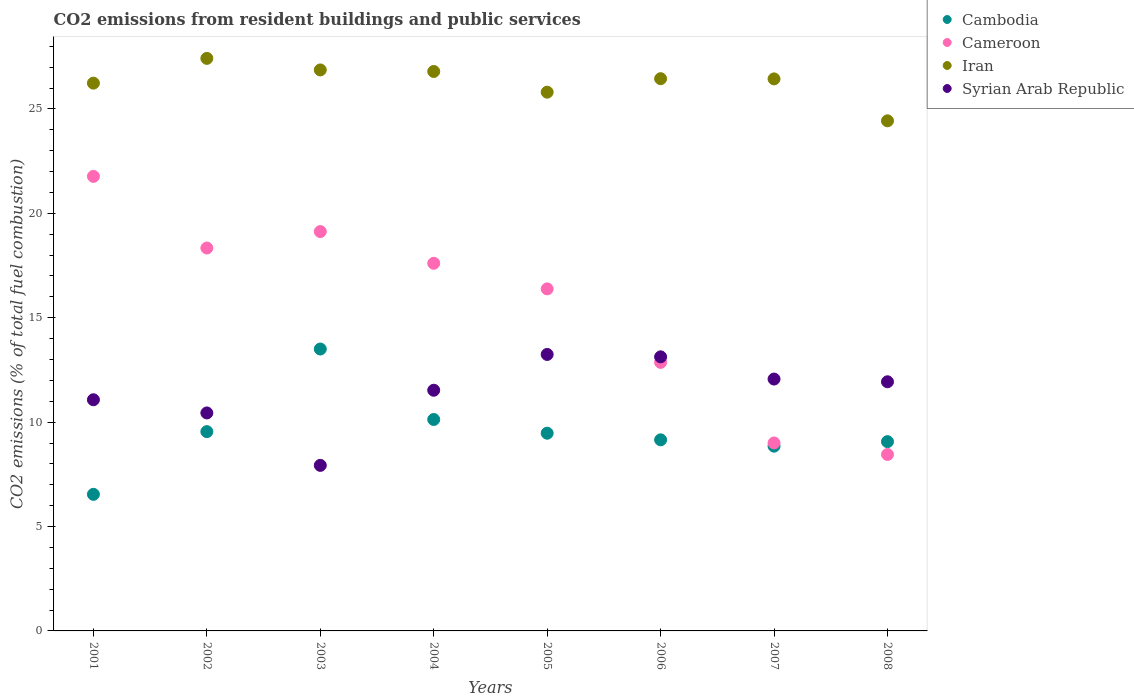How many different coloured dotlines are there?
Give a very brief answer. 4. What is the total CO2 emitted in Cameroon in 2005?
Your answer should be very brief. 16.38. Across all years, what is the maximum total CO2 emitted in Cameroon?
Your response must be concise. 21.77. Across all years, what is the minimum total CO2 emitted in Cambodia?
Offer a terse response. 6.54. In which year was the total CO2 emitted in Cambodia maximum?
Give a very brief answer. 2003. What is the total total CO2 emitted in Syrian Arab Republic in the graph?
Provide a succinct answer. 91.34. What is the difference between the total CO2 emitted in Cameroon in 2002 and that in 2008?
Your answer should be very brief. 9.89. What is the difference between the total CO2 emitted in Cambodia in 2001 and the total CO2 emitted in Syrian Arab Republic in 2005?
Provide a short and direct response. -6.7. What is the average total CO2 emitted in Iran per year?
Your answer should be very brief. 26.31. In the year 2004, what is the difference between the total CO2 emitted in Iran and total CO2 emitted in Cambodia?
Your answer should be compact. 16.67. What is the ratio of the total CO2 emitted in Syrian Arab Republic in 2003 to that in 2008?
Ensure brevity in your answer.  0.66. Is the total CO2 emitted in Cameroon in 2003 less than that in 2008?
Keep it short and to the point. No. Is the difference between the total CO2 emitted in Iran in 2003 and 2006 greater than the difference between the total CO2 emitted in Cambodia in 2003 and 2006?
Offer a terse response. No. What is the difference between the highest and the second highest total CO2 emitted in Cambodia?
Keep it short and to the point. 3.38. What is the difference between the highest and the lowest total CO2 emitted in Iran?
Provide a succinct answer. 2.99. In how many years, is the total CO2 emitted in Cameroon greater than the average total CO2 emitted in Cameroon taken over all years?
Offer a very short reply. 5. Is the sum of the total CO2 emitted in Cambodia in 2001 and 2002 greater than the maximum total CO2 emitted in Iran across all years?
Provide a short and direct response. No. Is the total CO2 emitted in Iran strictly greater than the total CO2 emitted in Cameroon over the years?
Keep it short and to the point. Yes. Is the total CO2 emitted in Syrian Arab Republic strictly less than the total CO2 emitted in Cambodia over the years?
Provide a succinct answer. No. How many years are there in the graph?
Provide a succinct answer. 8. Are the values on the major ticks of Y-axis written in scientific E-notation?
Give a very brief answer. No. Where does the legend appear in the graph?
Ensure brevity in your answer.  Top right. What is the title of the graph?
Ensure brevity in your answer.  CO2 emissions from resident buildings and public services. What is the label or title of the Y-axis?
Offer a very short reply. CO2 emissions (% of total fuel combustion). What is the CO2 emissions (% of total fuel combustion) in Cambodia in 2001?
Provide a short and direct response. 6.54. What is the CO2 emissions (% of total fuel combustion) in Cameroon in 2001?
Offer a very short reply. 21.77. What is the CO2 emissions (% of total fuel combustion) in Iran in 2001?
Keep it short and to the point. 26.24. What is the CO2 emissions (% of total fuel combustion) of Syrian Arab Republic in 2001?
Ensure brevity in your answer.  11.07. What is the CO2 emissions (% of total fuel combustion) of Cambodia in 2002?
Give a very brief answer. 9.55. What is the CO2 emissions (% of total fuel combustion) of Cameroon in 2002?
Make the answer very short. 18.34. What is the CO2 emissions (% of total fuel combustion) of Iran in 2002?
Offer a very short reply. 27.42. What is the CO2 emissions (% of total fuel combustion) of Syrian Arab Republic in 2002?
Provide a short and direct response. 10.44. What is the CO2 emissions (% of total fuel combustion) of Cambodia in 2003?
Your answer should be compact. 13.5. What is the CO2 emissions (% of total fuel combustion) in Cameroon in 2003?
Offer a terse response. 19.13. What is the CO2 emissions (% of total fuel combustion) in Iran in 2003?
Provide a short and direct response. 26.87. What is the CO2 emissions (% of total fuel combustion) of Syrian Arab Republic in 2003?
Ensure brevity in your answer.  7.93. What is the CO2 emissions (% of total fuel combustion) in Cambodia in 2004?
Your answer should be compact. 10.13. What is the CO2 emissions (% of total fuel combustion) in Cameroon in 2004?
Offer a very short reply. 17.61. What is the CO2 emissions (% of total fuel combustion) of Iran in 2004?
Give a very brief answer. 26.8. What is the CO2 emissions (% of total fuel combustion) in Syrian Arab Republic in 2004?
Your answer should be compact. 11.53. What is the CO2 emissions (% of total fuel combustion) of Cambodia in 2005?
Ensure brevity in your answer.  9.47. What is the CO2 emissions (% of total fuel combustion) of Cameroon in 2005?
Your answer should be compact. 16.38. What is the CO2 emissions (% of total fuel combustion) of Iran in 2005?
Your answer should be compact. 25.8. What is the CO2 emissions (% of total fuel combustion) in Syrian Arab Republic in 2005?
Provide a short and direct response. 13.24. What is the CO2 emissions (% of total fuel combustion) in Cambodia in 2006?
Provide a short and direct response. 9.15. What is the CO2 emissions (% of total fuel combustion) of Cameroon in 2006?
Provide a short and direct response. 12.86. What is the CO2 emissions (% of total fuel combustion) in Iran in 2006?
Provide a short and direct response. 26.45. What is the CO2 emissions (% of total fuel combustion) of Syrian Arab Republic in 2006?
Keep it short and to the point. 13.13. What is the CO2 emissions (% of total fuel combustion) in Cambodia in 2007?
Make the answer very short. 8.85. What is the CO2 emissions (% of total fuel combustion) of Cameroon in 2007?
Offer a terse response. 9. What is the CO2 emissions (% of total fuel combustion) in Iran in 2007?
Keep it short and to the point. 26.44. What is the CO2 emissions (% of total fuel combustion) of Syrian Arab Republic in 2007?
Your answer should be very brief. 12.06. What is the CO2 emissions (% of total fuel combustion) in Cambodia in 2008?
Your response must be concise. 9.07. What is the CO2 emissions (% of total fuel combustion) in Cameroon in 2008?
Keep it short and to the point. 8.45. What is the CO2 emissions (% of total fuel combustion) of Iran in 2008?
Ensure brevity in your answer.  24.43. What is the CO2 emissions (% of total fuel combustion) in Syrian Arab Republic in 2008?
Provide a short and direct response. 11.93. Across all years, what is the maximum CO2 emissions (% of total fuel combustion) of Cambodia?
Give a very brief answer. 13.5. Across all years, what is the maximum CO2 emissions (% of total fuel combustion) of Cameroon?
Ensure brevity in your answer.  21.77. Across all years, what is the maximum CO2 emissions (% of total fuel combustion) in Iran?
Keep it short and to the point. 27.42. Across all years, what is the maximum CO2 emissions (% of total fuel combustion) of Syrian Arab Republic?
Your answer should be very brief. 13.24. Across all years, what is the minimum CO2 emissions (% of total fuel combustion) of Cambodia?
Make the answer very short. 6.54. Across all years, what is the minimum CO2 emissions (% of total fuel combustion) of Cameroon?
Your response must be concise. 8.45. Across all years, what is the minimum CO2 emissions (% of total fuel combustion) of Iran?
Provide a short and direct response. 24.43. Across all years, what is the minimum CO2 emissions (% of total fuel combustion) in Syrian Arab Republic?
Keep it short and to the point. 7.93. What is the total CO2 emissions (% of total fuel combustion) in Cambodia in the graph?
Your answer should be very brief. 76.25. What is the total CO2 emissions (% of total fuel combustion) in Cameroon in the graph?
Ensure brevity in your answer.  123.54. What is the total CO2 emissions (% of total fuel combustion) of Iran in the graph?
Keep it short and to the point. 210.45. What is the total CO2 emissions (% of total fuel combustion) of Syrian Arab Republic in the graph?
Offer a terse response. 91.34. What is the difference between the CO2 emissions (% of total fuel combustion) of Cambodia in 2001 and that in 2002?
Ensure brevity in your answer.  -3. What is the difference between the CO2 emissions (% of total fuel combustion) of Cameroon in 2001 and that in 2002?
Provide a succinct answer. 3.43. What is the difference between the CO2 emissions (% of total fuel combustion) in Iran in 2001 and that in 2002?
Offer a terse response. -1.19. What is the difference between the CO2 emissions (% of total fuel combustion) in Syrian Arab Republic in 2001 and that in 2002?
Your answer should be very brief. 0.63. What is the difference between the CO2 emissions (% of total fuel combustion) in Cambodia in 2001 and that in 2003?
Give a very brief answer. -6.96. What is the difference between the CO2 emissions (% of total fuel combustion) of Cameroon in 2001 and that in 2003?
Provide a succinct answer. 2.64. What is the difference between the CO2 emissions (% of total fuel combustion) of Iran in 2001 and that in 2003?
Provide a short and direct response. -0.63. What is the difference between the CO2 emissions (% of total fuel combustion) in Syrian Arab Republic in 2001 and that in 2003?
Your response must be concise. 3.14. What is the difference between the CO2 emissions (% of total fuel combustion) of Cambodia in 2001 and that in 2004?
Provide a short and direct response. -3.58. What is the difference between the CO2 emissions (% of total fuel combustion) in Cameroon in 2001 and that in 2004?
Provide a succinct answer. 4.16. What is the difference between the CO2 emissions (% of total fuel combustion) in Iran in 2001 and that in 2004?
Ensure brevity in your answer.  -0.56. What is the difference between the CO2 emissions (% of total fuel combustion) in Syrian Arab Republic in 2001 and that in 2004?
Give a very brief answer. -0.46. What is the difference between the CO2 emissions (% of total fuel combustion) in Cambodia in 2001 and that in 2005?
Offer a terse response. -2.93. What is the difference between the CO2 emissions (% of total fuel combustion) of Cameroon in 2001 and that in 2005?
Keep it short and to the point. 5.39. What is the difference between the CO2 emissions (% of total fuel combustion) of Iran in 2001 and that in 2005?
Give a very brief answer. 0.43. What is the difference between the CO2 emissions (% of total fuel combustion) of Syrian Arab Republic in 2001 and that in 2005?
Your answer should be very brief. -2.17. What is the difference between the CO2 emissions (% of total fuel combustion) in Cambodia in 2001 and that in 2006?
Offer a very short reply. -2.61. What is the difference between the CO2 emissions (% of total fuel combustion) in Cameroon in 2001 and that in 2006?
Offer a terse response. 8.91. What is the difference between the CO2 emissions (% of total fuel combustion) of Iran in 2001 and that in 2006?
Your response must be concise. -0.21. What is the difference between the CO2 emissions (% of total fuel combustion) in Syrian Arab Republic in 2001 and that in 2006?
Your answer should be compact. -2.06. What is the difference between the CO2 emissions (% of total fuel combustion) in Cambodia in 2001 and that in 2007?
Your answer should be compact. -2.31. What is the difference between the CO2 emissions (% of total fuel combustion) of Cameroon in 2001 and that in 2007?
Ensure brevity in your answer.  12.77. What is the difference between the CO2 emissions (% of total fuel combustion) of Iran in 2001 and that in 2007?
Your answer should be compact. -0.2. What is the difference between the CO2 emissions (% of total fuel combustion) in Syrian Arab Republic in 2001 and that in 2007?
Offer a very short reply. -0.99. What is the difference between the CO2 emissions (% of total fuel combustion) of Cambodia in 2001 and that in 2008?
Offer a terse response. -2.52. What is the difference between the CO2 emissions (% of total fuel combustion) of Cameroon in 2001 and that in 2008?
Ensure brevity in your answer.  13.32. What is the difference between the CO2 emissions (% of total fuel combustion) of Iran in 2001 and that in 2008?
Make the answer very short. 1.8. What is the difference between the CO2 emissions (% of total fuel combustion) of Syrian Arab Republic in 2001 and that in 2008?
Your answer should be very brief. -0.86. What is the difference between the CO2 emissions (% of total fuel combustion) in Cambodia in 2002 and that in 2003?
Provide a succinct answer. -3.96. What is the difference between the CO2 emissions (% of total fuel combustion) in Cameroon in 2002 and that in 2003?
Ensure brevity in your answer.  -0.79. What is the difference between the CO2 emissions (% of total fuel combustion) of Iran in 2002 and that in 2003?
Keep it short and to the point. 0.55. What is the difference between the CO2 emissions (% of total fuel combustion) in Syrian Arab Republic in 2002 and that in 2003?
Keep it short and to the point. 2.51. What is the difference between the CO2 emissions (% of total fuel combustion) in Cambodia in 2002 and that in 2004?
Ensure brevity in your answer.  -0.58. What is the difference between the CO2 emissions (% of total fuel combustion) in Cameroon in 2002 and that in 2004?
Provide a short and direct response. 0.73. What is the difference between the CO2 emissions (% of total fuel combustion) of Iran in 2002 and that in 2004?
Provide a succinct answer. 0.63. What is the difference between the CO2 emissions (% of total fuel combustion) in Syrian Arab Republic in 2002 and that in 2004?
Make the answer very short. -1.09. What is the difference between the CO2 emissions (% of total fuel combustion) of Cambodia in 2002 and that in 2005?
Offer a very short reply. 0.08. What is the difference between the CO2 emissions (% of total fuel combustion) in Cameroon in 2002 and that in 2005?
Ensure brevity in your answer.  1.96. What is the difference between the CO2 emissions (% of total fuel combustion) of Iran in 2002 and that in 2005?
Give a very brief answer. 1.62. What is the difference between the CO2 emissions (% of total fuel combustion) in Syrian Arab Republic in 2002 and that in 2005?
Ensure brevity in your answer.  -2.8. What is the difference between the CO2 emissions (% of total fuel combustion) in Cambodia in 2002 and that in 2006?
Provide a short and direct response. 0.39. What is the difference between the CO2 emissions (% of total fuel combustion) of Cameroon in 2002 and that in 2006?
Your response must be concise. 5.48. What is the difference between the CO2 emissions (% of total fuel combustion) in Iran in 2002 and that in 2006?
Ensure brevity in your answer.  0.97. What is the difference between the CO2 emissions (% of total fuel combustion) of Syrian Arab Republic in 2002 and that in 2006?
Provide a short and direct response. -2.69. What is the difference between the CO2 emissions (% of total fuel combustion) in Cambodia in 2002 and that in 2007?
Provide a succinct answer. 0.7. What is the difference between the CO2 emissions (% of total fuel combustion) in Cameroon in 2002 and that in 2007?
Offer a very short reply. 9.34. What is the difference between the CO2 emissions (% of total fuel combustion) of Iran in 2002 and that in 2007?
Give a very brief answer. 0.98. What is the difference between the CO2 emissions (% of total fuel combustion) of Syrian Arab Republic in 2002 and that in 2007?
Offer a terse response. -1.62. What is the difference between the CO2 emissions (% of total fuel combustion) in Cambodia in 2002 and that in 2008?
Offer a very short reply. 0.48. What is the difference between the CO2 emissions (% of total fuel combustion) of Cameroon in 2002 and that in 2008?
Your answer should be very brief. 9.89. What is the difference between the CO2 emissions (% of total fuel combustion) of Iran in 2002 and that in 2008?
Your response must be concise. 2.99. What is the difference between the CO2 emissions (% of total fuel combustion) in Syrian Arab Republic in 2002 and that in 2008?
Your answer should be very brief. -1.49. What is the difference between the CO2 emissions (% of total fuel combustion) in Cambodia in 2003 and that in 2004?
Your response must be concise. 3.38. What is the difference between the CO2 emissions (% of total fuel combustion) of Cameroon in 2003 and that in 2004?
Your answer should be compact. 1.52. What is the difference between the CO2 emissions (% of total fuel combustion) in Iran in 2003 and that in 2004?
Provide a short and direct response. 0.07. What is the difference between the CO2 emissions (% of total fuel combustion) in Syrian Arab Republic in 2003 and that in 2004?
Make the answer very short. -3.6. What is the difference between the CO2 emissions (% of total fuel combustion) of Cambodia in 2003 and that in 2005?
Your answer should be very brief. 4.03. What is the difference between the CO2 emissions (% of total fuel combustion) of Cameroon in 2003 and that in 2005?
Offer a very short reply. 2.75. What is the difference between the CO2 emissions (% of total fuel combustion) in Iran in 2003 and that in 2005?
Provide a succinct answer. 1.07. What is the difference between the CO2 emissions (% of total fuel combustion) of Syrian Arab Republic in 2003 and that in 2005?
Keep it short and to the point. -5.31. What is the difference between the CO2 emissions (% of total fuel combustion) in Cambodia in 2003 and that in 2006?
Your response must be concise. 4.35. What is the difference between the CO2 emissions (% of total fuel combustion) of Cameroon in 2003 and that in 2006?
Provide a succinct answer. 6.27. What is the difference between the CO2 emissions (% of total fuel combustion) in Iran in 2003 and that in 2006?
Ensure brevity in your answer.  0.42. What is the difference between the CO2 emissions (% of total fuel combustion) of Syrian Arab Republic in 2003 and that in 2006?
Ensure brevity in your answer.  -5.2. What is the difference between the CO2 emissions (% of total fuel combustion) of Cambodia in 2003 and that in 2007?
Your response must be concise. 4.65. What is the difference between the CO2 emissions (% of total fuel combustion) of Cameroon in 2003 and that in 2007?
Provide a short and direct response. 10.13. What is the difference between the CO2 emissions (% of total fuel combustion) in Iran in 2003 and that in 2007?
Your answer should be very brief. 0.43. What is the difference between the CO2 emissions (% of total fuel combustion) of Syrian Arab Republic in 2003 and that in 2007?
Offer a very short reply. -4.13. What is the difference between the CO2 emissions (% of total fuel combustion) in Cambodia in 2003 and that in 2008?
Your answer should be compact. 4.44. What is the difference between the CO2 emissions (% of total fuel combustion) of Cameroon in 2003 and that in 2008?
Ensure brevity in your answer.  10.68. What is the difference between the CO2 emissions (% of total fuel combustion) in Iran in 2003 and that in 2008?
Your response must be concise. 2.44. What is the difference between the CO2 emissions (% of total fuel combustion) in Syrian Arab Republic in 2003 and that in 2008?
Your response must be concise. -4. What is the difference between the CO2 emissions (% of total fuel combustion) in Cambodia in 2004 and that in 2005?
Your response must be concise. 0.66. What is the difference between the CO2 emissions (% of total fuel combustion) in Cameroon in 2004 and that in 2005?
Your answer should be compact. 1.23. What is the difference between the CO2 emissions (% of total fuel combustion) of Syrian Arab Republic in 2004 and that in 2005?
Provide a succinct answer. -1.71. What is the difference between the CO2 emissions (% of total fuel combustion) of Cambodia in 2004 and that in 2006?
Provide a succinct answer. 0.97. What is the difference between the CO2 emissions (% of total fuel combustion) of Cameroon in 2004 and that in 2006?
Your answer should be compact. 4.75. What is the difference between the CO2 emissions (% of total fuel combustion) of Iran in 2004 and that in 2006?
Provide a short and direct response. 0.35. What is the difference between the CO2 emissions (% of total fuel combustion) of Syrian Arab Republic in 2004 and that in 2006?
Provide a short and direct response. -1.6. What is the difference between the CO2 emissions (% of total fuel combustion) in Cambodia in 2004 and that in 2007?
Provide a short and direct response. 1.28. What is the difference between the CO2 emissions (% of total fuel combustion) of Cameroon in 2004 and that in 2007?
Keep it short and to the point. 8.61. What is the difference between the CO2 emissions (% of total fuel combustion) in Iran in 2004 and that in 2007?
Make the answer very short. 0.36. What is the difference between the CO2 emissions (% of total fuel combustion) in Syrian Arab Republic in 2004 and that in 2007?
Provide a short and direct response. -0.54. What is the difference between the CO2 emissions (% of total fuel combustion) in Cambodia in 2004 and that in 2008?
Your answer should be compact. 1.06. What is the difference between the CO2 emissions (% of total fuel combustion) of Cameroon in 2004 and that in 2008?
Your answer should be compact. 9.16. What is the difference between the CO2 emissions (% of total fuel combustion) of Iran in 2004 and that in 2008?
Make the answer very short. 2.36. What is the difference between the CO2 emissions (% of total fuel combustion) in Syrian Arab Republic in 2004 and that in 2008?
Provide a short and direct response. -0.41. What is the difference between the CO2 emissions (% of total fuel combustion) in Cambodia in 2005 and that in 2006?
Ensure brevity in your answer.  0.32. What is the difference between the CO2 emissions (% of total fuel combustion) of Cameroon in 2005 and that in 2006?
Give a very brief answer. 3.52. What is the difference between the CO2 emissions (% of total fuel combustion) of Iran in 2005 and that in 2006?
Your answer should be compact. -0.65. What is the difference between the CO2 emissions (% of total fuel combustion) of Syrian Arab Republic in 2005 and that in 2006?
Ensure brevity in your answer.  0.11. What is the difference between the CO2 emissions (% of total fuel combustion) in Cambodia in 2005 and that in 2007?
Offer a terse response. 0.62. What is the difference between the CO2 emissions (% of total fuel combustion) of Cameroon in 2005 and that in 2007?
Ensure brevity in your answer.  7.38. What is the difference between the CO2 emissions (% of total fuel combustion) of Iran in 2005 and that in 2007?
Offer a very short reply. -0.64. What is the difference between the CO2 emissions (% of total fuel combustion) in Syrian Arab Republic in 2005 and that in 2007?
Make the answer very short. 1.18. What is the difference between the CO2 emissions (% of total fuel combustion) of Cambodia in 2005 and that in 2008?
Ensure brevity in your answer.  0.4. What is the difference between the CO2 emissions (% of total fuel combustion) of Cameroon in 2005 and that in 2008?
Your answer should be very brief. 7.93. What is the difference between the CO2 emissions (% of total fuel combustion) of Iran in 2005 and that in 2008?
Offer a very short reply. 1.37. What is the difference between the CO2 emissions (% of total fuel combustion) in Syrian Arab Republic in 2005 and that in 2008?
Your response must be concise. 1.31. What is the difference between the CO2 emissions (% of total fuel combustion) of Cambodia in 2006 and that in 2007?
Make the answer very short. 0.3. What is the difference between the CO2 emissions (% of total fuel combustion) in Cameroon in 2006 and that in 2007?
Ensure brevity in your answer.  3.86. What is the difference between the CO2 emissions (% of total fuel combustion) of Iran in 2006 and that in 2007?
Provide a succinct answer. 0.01. What is the difference between the CO2 emissions (% of total fuel combustion) in Syrian Arab Republic in 2006 and that in 2007?
Provide a succinct answer. 1.06. What is the difference between the CO2 emissions (% of total fuel combustion) in Cambodia in 2006 and that in 2008?
Your response must be concise. 0.09. What is the difference between the CO2 emissions (% of total fuel combustion) of Cameroon in 2006 and that in 2008?
Ensure brevity in your answer.  4.41. What is the difference between the CO2 emissions (% of total fuel combustion) in Iran in 2006 and that in 2008?
Provide a short and direct response. 2.02. What is the difference between the CO2 emissions (% of total fuel combustion) of Syrian Arab Republic in 2006 and that in 2008?
Provide a short and direct response. 1.19. What is the difference between the CO2 emissions (% of total fuel combustion) in Cambodia in 2007 and that in 2008?
Your answer should be compact. -0.22. What is the difference between the CO2 emissions (% of total fuel combustion) of Cameroon in 2007 and that in 2008?
Provide a succinct answer. 0.55. What is the difference between the CO2 emissions (% of total fuel combustion) of Iran in 2007 and that in 2008?
Your answer should be very brief. 2.01. What is the difference between the CO2 emissions (% of total fuel combustion) of Syrian Arab Republic in 2007 and that in 2008?
Ensure brevity in your answer.  0.13. What is the difference between the CO2 emissions (% of total fuel combustion) in Cambodia in 2001 and the CO2 emissions (% of total fuel combustion) in Cameroon in 2002?
Provide a succinct answer. -11.8. What is the difference between the CO2 emissions (% of total fuel combustion) in Cambodia in 2001 and the CO2 emissions (% of total fuel combustion) in Iran in 2002?
Offer a very short reply. -20.88. What is the difference between the CO2 emissions (% of total fuel combustion) of Cambodia in 2001 and the CO2 emissions (% of total fuel combustion) of Syrian Arab Republic in 2002?
Offer a very short reply. -3.9. What is the difference between the CO2 emissions (% of total fuel combustion) of Cameroon in 2001 and the CO2 emissions (% of total fuel combustion) of Iran in 2002?
Provide a succinct answer. -5.65. What is the difference between the CO2 emissions (% of total fuel combustion) in Cameroon in 2001 and the CO2 emissions (% of total fuel combustion) in Syrian Arab Republic in 2002?
Make the answer very short. 11.33. What is the difference between the CO2 emissions (% of total fuel combustion) of Iran in 2001 and the CO2 emissions (% of total fuel combustion) of Syrian Arab Republic in 2002?
Provide a succinct answer. 15.8. What is the difference between the CO2 emissions (% of total fuel combustion) in Cambodia in 2001 and the CO2 emissions (% of total fuel combustion) in Cameroon in 2003?
Provide a succinct answer. -12.59. What is the difference between the CO2 emissions (% of total fuel combustion) in Cambodia in 2001 and the CO2 emissions (% of total fuel combustion) in Iran in 2003?
Provide a short and direct response. -20.33. What is the difference between the CO2 emissions (% of total fuel combustion) of Cambodia in 2001 and the CO2 emissions (% of total fuel combustion) of Syrian Arab Republic in 2003?
Provide a short and direct response. -1.39. What is the difference between the CO2 emissions (% of total fuel combustion) of Cameroon in 2001 and the CO2 emissions (% of total fuel combustion) of Iran in 2003?
Your response must be concise. -5.1. What is the difference between the CO2 emissions (% of total fuel combustion) of Cameroon in 2001 and the CO2 emissions (% of total fuel combustion) of Syrian Arab Republic in 2003?
Your response must be concise. 13.84. What is the difference between the CO2 emissions (% of total fuel combustion) of Iran in 2001 and the CO2 emissions (% of total fuel combustion) of Syrian Arab Republic in 2003?
Your response must be concise. 18.31. What is the difference between the CO2 emissions (% of total fuel combustion) of Cambodia in 2001 and the CO2 emissions (% of total fuel combustion) of Cameroon in 2004?
Your answer should be compact. -11.07. What is the difference between the CO2 emissions (% of total fuel combustion) of Cambodia in 2001 and the CO2 emissions (% of total fuel combustion) of Iran in 2004?
Your response must be concise. -20.25. What is the difference between the CO2 emissions (% of total fuel combustion) of Cambodia in 2001 and the CO2 emissions (% of total fuel combustion) of Syrian Arab Republic in 2004?
Your answer should be very brief. -4.99. What is the difference between the CO2 emissions (% of total fuel combustion) of Cameroon in 2001 and the CO2 emissions (% of total fuel combustion) of Iran in 2004?
Give a very brief answer. -5.02. What is the difference between the CO2 emissions (% of total fuel combustion) of Cameroon in 2001 and the CO2 emissions (% of total fuel combustion) of Syrian Arab Republic in 2004?
Your response must be concise. 10.24. What is the difference between the CO2 emissions (% of total fuel combustion) in Iran in 2001 and the CO2 emissions (% of total fuel combustion) in Syrian Arab Republic in 2004?
Your answer should be compact. 14.71. What is the difference between the CO2 emissions (% of total fuel combustion) of Cambodia in 2001 and the CO2 emissions (% of total fuel combustion) of Cameroon in 2005?
Your answer should be compact. -9.84. What is the difference between the CO2 emissions (% of total fuel combustion) of Cambodia in 2001 and the CO2 emissions (% of total fuel combustion) of Iran in 2005?
Offer a terse response. -19.26. What is the difference between the CO2 emissions (% of total fuel combustion) of Cambodia in 2001 and the CO2 emissions (% of total fuel combustion) of Syrian Arab Republic in 2005?
Your answer should be very brief. -6.7. What is the difference between the CO2 emissions (% of total fuel combustion) in Cameroon in 2001 and the CO2 emissions (% of total fuel combustion) in Iran in 2005?
Provide a short and direct response. -4.03. What is the difference between the CO2 emissions (% of total fuel combustion) in Cameroon in 2001 and the CO2 emissions (% of total fuel combustion) in Syrian Arab Republic in 2005?
Keep it short and to the point. 8.53. What is the difference between the CO2 emissions (% of total fuel combustion) in Iran in 2001 and the CO2 emissions (% of total fuel combustion) in Syrian Arab Republic in 2005?
Your response must be concise. 12.99. What is the difference between the CO2 emissions (% of total fuel combustion) in Cambodia in 2001 and the CO2 emissions (% of total fuel combustion) in Cameroon in 2006?
Make the answer very short. -6.32. What is the difference between the CO2 emissions (% of total fuel combustion) of Cambodia in 2001 and the CO2 emissions (% of total fuel combustion) of Iran in 2006?
Ensure brevity in your answer.  -19.91. What is the difference between the CO2 emissions (% of total fuel combustion) of Cambodia in 2001 and the CO2 emissions (% of total fuel combustion) of Syrian Arab Republic in 2006?
Give a very brief answer. -6.59. What is the difference between the CO2 emissions (% of total fuel combustion) in Cameroon in 2001 and the CO2 emissions (% of total fuel combustion) in Iran in 2006?
Provide a short and direct response. -4.68. What is the difference between the CO2 emissions (% of total fuel combustion) of Cameroon in 2001 and the CO2 emissions (% of total fuel combustion) of Syrian Arab Republic in 2006?
Keep it short and to the point. 8.64. What is the difference between the CO2 emissions (% of total fuel combustion) in Iran in 2001 and the CO2 emissions (% of total fuel combustion) in Syrian Arab Republic in 2006?
Give a very brief answer. 13.11. What is the difference between the CO2 emissions (% of total fuel combustion) of Cambodia in 2001 and the CO2 emissions (% of total fuel combustion) of Cameroon in 2007?
Offer a terse response. -2.46. What is the difference between the CO2 emissions (% of total fuel combustion) in Cambodia in 2001 and the CO2 emissions (% of total fuel combustion) in Iran in 2007?
Provide a short and direct response. -19.9. What is the difference between the CO2 emissions (% of total fuel combustion) of Cambodia in 2001 and the CO2 emissions (% of total fuel combustion) of Syrian Arab Republic in 2007?
Ensure brevity in your answer.  -5.52. What is the difference between the CO2 emissions (% of total fuel combustion) of Cameroon in 2001 and the CO2 emissions (% of total fuel combustion) of Iran in 2007?
Give a very brief answer. -4.67. What is the difference between the CO2 emissions (% of total fuel combustion) in Cameroon in 2001 and the CO2 emissions (% of total fuel combustion) in Syrian Arab Republic in 2007?
Offer a very short reply. 9.71. What is the difference between the CO2 emissions (% of total fuel combustion) in Iran in 2001 and the CO2 emissions (% of total fuel combustion) in Syrian Arab Republic in 2007?
Offer a terse response. 14.17. What is the difference between the CO2 emissions (% of total fuel combustion) of Cambodia in 2001 and the CO2 emissions (% of total fuel combustion) of Cameroon in 2008?
Offer a terse response. -1.91. What is the difference between the CO2 emissions (% of total fuel combustion) in Cambodia in 2001 and the CO2 emissions (% of total fuel combustion) in Iran in 2008?
Ensure brevity in your answer.  -17.89. What is the difference between the CO2 emissions (% of total fuel combustion) of Cambodia in 2001 and the CO2 emissions (% of total fuel combustion) of Syrian Arab Republic in 2008?
Your answer should be very brief. -5.39. What is the difference between the CO2 emissions (% of total fuel combustion) in Cameroon in 2001 and the CO2 emissions (% of total fuel combustion) in Iran in 2008?
Make the answer very short. -2.66. What is the difference between the CO2 emissions (% of total fuel combustion) in Cameroon in 2001 and the CO2 emissions (% of total fuel combustion) in Syrian Arab Republic in 2008?
Give a very brief answer. 9.84. What is the difference between the CO2 emissions (% of total fuel combustion) of Iran in 2001 and the CO2 emissions (% of total fuel combustion) of Syrian Arab Republic in 2008?
Offer a terse response. 14.3. What is the difference between the CO2 emissions (% of total fuel combustion) in Cambodia in 2002 and the CO2 emissions (% of total fuel combustion) in Cameroon in 2003?
Ensure brevity in your answer.  -9.58. What is the difference between the CO2 emissions (% of total fuel combustion) of Cambodia in 2002 and the CO2 emissions (% of total fuel combustion) of Iran in 2003?
Make the answer very short. -17.32. What is the difference between the CO2 emissions (% of total fuel combustion) of Cambodia in 2002 and the CO2 emissions (% of total fuel combustion) of Syrian Arab Republic in 2003?
Keep it short and to the point. 1.62. What is the difference between the CO2 emissions (% of total fuel combustion) of Cameroon in 2002 and the CO2 emissions (% of total fuel combustion) of Iran in 2003?
Your answer should be very brief. -8.53. What is the difference between the CO2 emissions (% of total fuel combustion) in Cameroon in 2002 and the CO2 emissions (% of total fuel combustion) in Syrian Arab Republic in 2003?
Offer a terse response. 10.41. What is the difference between the CO2 emissions (% of total fuel combustion) of Iran in 2002 and the CO2 emissions (% of total fuel combustion) of Syrian Arab Republic in 2003?
Provide a succinct answer. 19.49. What is the difference between the CO2 emissions (% of total fuel combustion) of Cambodia in 2002 and the CO2 emissions (% of total fuel combustion) of Cameroon in 2004?
Your response must be concise. -8.06. What is the difference between the CO2 emissions (% of total fuel combustion) of Cambodia in 2002 and the CO2 emissions (% of total fuel combustion) of Iran in 2004?
Provide a short and direct response. -17.25. What is the difference between the CO2 emissions (% of total fuel combustion) of Cambodia in 2002 and the CO2 emissions (% of total fuel combustion) of Syrian Arab Republic in 2004?
Your response must be concise. -1.98. What is the difference between the CO2 emissions (% of total fuel combustion) in Cameroon in 2002 and the CO2 emissions (% of total fuel combustion) in Iran in 2004?
Keep it short and to the point. -8.46. What is the difference between the CO2 emissions (% of total fuel combustion) in Cameroon in 2002 and the CO2 emissions (% of total fuel combustion) in Syrian Arab Republic in 2004?
Your answer should be compact. 6.81. What is the difference between the CO2 emissions (% of total fuel combustion) in Iran in 2002 and the CO2 emissions (% of total fuel combustion) in Syrian Arab Republic in 2004?
Ensure brevity in your answer.  15.9. What is the difference between the CO2 emissions (% of total fuel combustion) of Cambodia in 2002 and the CO2 emissions (% of total fuel combustion) of Cameroon in 2005?
Make the answer very short. -6.84. What is the difference between the CO2 emissions (% of total fuel combustion) in Cambodia in 2002 and the CO2 emissions (% of total fuel combustion) in Iran in 2005?
Your answer should be very brief. -16.26. What is the difference between the CO2 emissions (% of total fuel combustion) in Cambodia in 2002 and the CO2 emissions (% of total fuel combustion) in Syrian Arab Republic in 2005?
Ensure brevity in your answer.  -3.7. What is the difference between the CO2 emissions (% of total fuel combustion) of Cameroon in 2002 and the CO2 emissions (% of total fuel combustion) of Iran in 2005?
Provide a succinct answer. -7.46. What is the difference between the CO2 emissions (% of total fuel combustion) of Cameroon in 2002 and the CO2 emissions (% of total fuel combustion) of Syrian Arab Republic in 2005?
Offer a very short reply. 5.1. What is the difference between the CO2 emissions (% of total fuel combustion) in Iran in 2002 and the CO2 emissions (% of total fuel combustion) in Syrian Arab Republic in 2005?
Offer a terse response. 14.18. What is the difference between the CO2 emissions (% of total fuel combustion) of Cambodia in 2002 and the CO2 emissions (% of total fuel combustion) of Cameroon in 2006?
Make the answer very short. -3.32. What is the difference between the CO2 emissions (% of total fuel combustion) in Cambodia in 2002 and the CO2 emissions (% of total fuel combustion) in Iran in 2006?
Give a very brief answer. -16.9. What is the difference between the CO2 emissions (% of total fuel combustion) of Cambodia in 2002 and the CO2 emissions (% of total fuel combustion) of Syrian Arab Republic in 2006?
Provide a succinct answer. -3.58. What is the difference between the CO2 emissions (% of total fuel combustion) of Cameroon in 2002 and the CO2 emissions (% of total fuel combustion) of Iran in 2006?
Your response must be concise. -8.11. What is the difference between the CO2 emissions (% of total fuel combustion) in Cameroon in 2002 and the CO2 emissions (% of total fuel combustion) in Syrian Arab Republic in 2006?
Provide a succinct answer. 5.21. What is the difference between the CO2 emissions (% of total fuel combustion) in Iran in 2002 and the CO2 emissions (% of total fuel combustion) in Syrian Arab Republic in 2006?
Your response must be concise. 14.3. What is the difference between the CO2 emissions (% of total fuel combustion) in Cambodia in 2002 and the CO2 emissions (% of total fuel combustion) in Cameroon in 2007?
Give a very brief answer. 0.54. What is the difference between the CO2 emissions (% of total fuel combustion) in Cambodia in 2002 and the CO2 emissions (% of total fuel combustion) in Iran in 2007?
Offer a very short reply. -16.89. What is the difference between the CO2 emissions (% of total fuel combustion) in Cambodia in 2002 and the CO2 emissions (% of total fuel combustion) in Syrian Arab Republic in 2007?
Provide a short and direct response. -2.52. What is the difference between the CO2 emissions (% of total fuel combustion) of Cameroon in 2002 and the CO2 emissions (% of total fuel combustion) of Iran in 2007?
Your response must be concise. -8.1. What is the difference between the CO2 emissions (% of total fuel combustion) of Cameroon in 2002 and the CO2 emissions (% of total fuel combustion) of Syrian Arab Republic in 2007?
Provide a succinct answer. 6.28. What is the difference between the CO2 emissions (% of total fuel combustion) of Iran in 2002 and the CO2 emissions (% of total fuel combustion) of Syrian Arab Republic in 2007?
Provide a short and direct response. 15.36. What is the difference between the CO2 emissions (% of total fuel combustion) of Cambodia in 2002 and the CO2 emissions (% of total fuel combustion) of Cameroon in 2008?
Ensure brevity in your answer.  1.09. What is the difference between the CO2 emissions (% of total fuel combustion) of Cambodia in 2002 and the CO2 emissions (% of total fuel combustion) of Iran in 2008?
Your answer should be very brief. -14.89. What is the difference between the CO2 emissions (% of total fuel combustion) of Cambodia in 2002 and the CO2 emissions (% of total fuel combustion) of Syrian Arab Republic in 2008?
Offer a terse response. -2.39. What is the difference between the CO2 emissions (% of total fuel combustion) in Cameroon in 2002 and the CO2 emissions (% of total fuel combustion) in Iran in 2008?
Provide a short and direct response. -6.09. What is the difference between the CO2 emissions (% of total fuel combustion) of Cameroon in 2002 and the CO2 emissions (% of total fuel combustion) of Syrian Arab Republic in 2008?
Offer a very short reply. 6.41. What is the difference between the CO2 emissions (% of total fuel combustion) of Iran in 2002 and the CO2 emissions (% of total fuel combustion) of Syrian Arab Republic in 2008?
Your answer should be compact. 15.49. What is the difference between the CO2 emissions (% of total fuel combustion) in Cambodia in 2003 and the CO2 emissions (% of total fuel combustion) in Cameroon in 2004?
Keep it short and to the point. -4.11. What is the difference between the CO2 emissions (% of total fuel combustion) in Cambodia in 2003 and the CO2 emissions (% of total fuel combustion) in Iran in 2004?
Offer a very short reply. -13.29. What is the difference between the CO2 emissions (% of total fuel combustion) of Cambodia in 2003 and the CO2 emissions (% of total fuel combustion) of Syrian Arab Republic in 2004?
Your answer should be compact. 1.97. What is the difference between the CO2 emissions (% of total fuel combustion) in Cameroon in 2003 and the CO2 emissions (% of total fuel combustion) in Iran in 2004?
Offer a very short reply. -7.67. What is the difference between the CO2 emissions (% of total fuel combustion) in Cameroon in 2003 and the CO2 emissions (% of total fuel combustion) in Syrian Arab Republic in 2004?
Your response must be concise. 7.6. What is the difference between the CO2 emissions (% of total fuel combustion) of Iran in 2003 and the CO2 emissions (% of total fuel combustion) of Syrian Arab Republic in 2004?
Your response must be concise. 15.34. What is the difference between the CO2 emissions (% of total fuel combustion) in Cambodia in 2003 and the CO2 emissions (% of total fuel combustion) in Cameroon in 2005?
Provide a short and direct response. -2.88. What is the difference between the CO2 emissions (% of total fuel combustion) of Cambodia in 2003 and the CO2 emissions (% of total fuel combustion) of Iran in 2005?
Your response must be concise. -12.3. What is the difference between the CO2 emissions (% of total fuel combustion) of Cambodia in 2003 and the CO2 emissions (% of total fuel combustion) of Syrian Arab Republic in 2005?
Your response must be concise. 0.26. What is the difference between the CO2 emissions (% of total fuel combustion) of Cameroon in 2003 and the CO2 emissions (% of total fuel combustion) of Iran in 2005?
Ensure brevity in your answer.  -6.68. What is the difference between the CO2 emissions (% of total fuel combustion) in Cameroon in 2003 and the CO2 emissions (% of total fuel combustion) in Syrian Arab Republic in 2005?
Make the answer very short. 5.89. What is the difference between the CO2 emissions (% of total fuel combustion) of Iran in 2003 and the CO2 emissions (% of total fuel combustion) of Syrian Arab Republic in 2005?
Your answer should be compact. 13.63. What is the difference between the CO2 emissions (% of total fuel combustion) of Cambodia in 2003 and the CO2 emissions (% of total fuel combustion) of Cameroon in 2006?
Ensure brevity in your answer.  0.64. What is the difference between the CO2 emissions (% of total fuel combustion) in Cambodia in 2003 and the CO2 emissions (% of total fuel combustion) in Iran in 2006?
Make the answer very short. -12.95. What is the difference between the CO2 emissions (% of total fuel combustion) of Cambodia in 2003 and the CO2 emissions (% of total fuel combustion) of Syrian Arab Republic in 2006?
Keep it short and to the point. 0.37. What is the difference between the CO2 emissions (% of total fuel combustion) in Cameroon in 2003 and the CO2 emissions (% of total fuel combustion) in Iran in 2006?
Your answer should be compact. -7.32. What is the difference between the CO2 emissions (% of total fuel combustion) in Cameroon in 2003 and the CO2 emissions (% of total fuel combustion) in Syrian Arab Republic in 2006?
Offer a very short reply. 6. What is the difference between the CO2 emissions (% of total fuel combustion) of Iran in 2003 and the CO2 emissions (% of total fuel combustion) of Syrian Arab Republic in 2006?
Your response must be concise. 13.74. What is the difference between the CO2 emissions (% of total fuel combustion) in Cambodia in 2003 and the CO2 emissions (% of total fuel combustion) in Cameroon in 2007?
Your response must be concise. 4.5. What is the difference between the CO2 emissions (% of total fuel combustion) of Cambodia in 2003 and the CO2 emissions (% of total fuel combustion) of Iran in 2007?
Keep it short and to the point. -12.94. What is the difference between the CO2 emissions (% of total fuel combustion) in Cambodia in 2003 and the CO2 emissions (% of total fuel combustion) in Syrian Arab Republic in 2007?
Your answer should be very brief. 1.44. What is the difference between the CO2 emissions (% of total fuel combustion) in Cameroon in 2003 and the CO2 emissions (% of total fuel combustion) in Iran in 2007?
Keep it short and to the point. -7.31. What is the difference between the CO2 emissions (% of total fuel combustion) of Cameroon in 2003 and the CO2 emissions (% of total fuel combustion) of Syrian Arab Republic in 2007?
Ensure brevity in your answer.  7.06. What is the difference between the CO2 emissions (% of total fuel combustion) in Iran in 2003 and the CO2 emissions (% of total fuel combustion) in Syrian Arab Republic in 2007?
Your response must be concise. 14.81. What is the difference between the CO2 emissions (% of total fuel combustion) in Cambodia in 2003 and the CO2 emissions (% of total fuel combustion) in Cameroon in 2008?
Provide a succinct answer. 5.05. What is the difference between the CO2 emissions (% of total fuel combustion) in Cambodia in 2003 and the CO2 emissions (% of total fuel combustion) in Iran in 2008?
Keep it short and to the point. -10.93. What is the difference between the CO2 emissions (% of total fuel combustion) of Cambodia in 2003 and the CO2 emissions (% of total fuel combustion) of Syrian Arab Republic in 2008?
Offer a terse response. 1.57. What is the difference between the CO2 emissions (% of total fuel combustion) in Cameroon in 2003 and the CO2 emissions (% of total fuel combustion) in Iran in 2008?
Your answer should be very brief. -5.3. What is the difference between the CO2 emissions (% of total fuel combustion) of Cameroon in 2003 and the CO2 emissions (% of total fuel combustion) of Syrian Arab Republic in 2008?
Your answer should be very brief. 7.19. What is the difference between the CO2 emissions (% of total fuel combustion) in Iran in 2003 and the CO2 emissions (% of total fuel combustion) in Syrian Arab Republic in 2008?
Offer a very short reply. 14.94. What is the difference between the CO2 emissions (% of total fuel combustion) of Cambodia in 2004 and the CO2 emissions (% of total fuel combustion) of Cameroon in 2005?
Your response must be concise. -6.26. What is the difference between the CO2 emissions (% of total fuel combustion) of Cambodia in 2004 and the CO2 emissions (% of total fuel combustion) of Iran in 2005?
Give a very brief answer. -15.68. What is the difference between the CO2 emissions (% of total fuel combustion) of Cambodia in 2004 and the CO2 emissions (% of total fuel combustion) of Syrian Arab Republic in 2005?
Keep it short and to the point. -3.12. What is the difference between the CO2 emissions (% of total fuel combustion) in Cameroon in 2004 and the CO2 emissions (% of total fuel combustion) in Iran in 2005?
Offer a terse response. -8.2. What is the difference between the CO2 emissions (% of total fuel combustion) of Cameroon in 2004 and the CO2 emissions (% of total fuel combustion) of Syrian Arab Republic in 2005?
Keep it short and to the point. 4.37. What is the difference between the CO2 emissions (% of total fuel combustion) in Iran in 2004 and the CO2 emissions (% of total fuel combustion) in Syrian Arab Republic in 2005?
Provide a short and direct response. 13.55. What is the difference between the CO2 emissions (% of total fuel combustion) of Cambodia in 2004 and the CO2 emissions (% of total fuel combustion) of Cameroon in 2006?
Offer a very short reply. -2.74. What is the difference between the CO2 emissions (% of total fuel combustion) of Cambodia in 2004 and the CO2 emissions (% of total fuel combustion) of Iran in 2006?
Keep it short and to the point. -16.32. What is the difference between the CO2 emissions (% of total fuel combustion) in Cambodia in 2004 and the CO2 emissions (% of total fuel combustion) in Syrian Arab Republic in 2006?
Provide a short and direct response. -3. What is the difference between the CO2 emissions (% of total fuel combustion) of Cameroon in 2004 and the CO2 emissions (% of total fuel combustion) of Iran in 2006?
Your response must be concise. -8.84. What is the difference between the CO2 emissions (% of total fuel combustion) of Cameroon in 2004 and the CO2 emissions (% of total fuel combustion) of Syrian Arab Republic in 2006?
Provide a succinct answer. 4.48. What is the difference between the CO2 emissions (% of total fuel combustion) in Iran in 2004 and the CO2 emissions (% of total fuel combustion) in Syrian Arab Republic in 2006?
Give a very brief answer. 13.67. What is the difference between the CO2 emissions (% of total fuel combustion) of Cambodia in 2004 and the CO2 emissions (% of total fuel combustion) of Cameroon in 2007?
Give a very brief answer. 1.12. What is the difference between the CO2 emissions (% of total fuel combustion) in Cambodia in 2004 and the CO2 emissions (% of total fuel combustion) in Iran in 2007?
Your response must be concise. -16.31. What is the difference between the CO2 emissions (% of total fuel combustion) of Cambodia in 2004 and the CO2 emissions (% of total fuel combustion) of Syrian Arab Republic in 2007?
Your response must be concise. -1.94. What is the difference between the CO2 emissions (% of total fuel combustion) in Cameroon in 2004 and the CO2 emissions (% of total fuel combustion) in Iran in 2007?
Provide a short and direct response. -8.83. What is the difference between the CO2 emissions (% of total fuel combustion) in Cameroon in 2004 and the CO2 emissions (% of total fuel combustion) in Syrian Arab Republic in 2007?
Your answer should be compact. 5.54. What is the difference between the CO2 emissions (% of total fuel combustion) of Iran in 2004 and the CO2 emissions (% of total fuel combustion) of Syrian Arab Republic in 2007?
Make the answer very short. 14.73. What is the difference between the CO2 emissions (% of total fuel combustion) of Cambodia in 2004 and the CO2 emissions (% of total fuel combustion) of Cameroon in 2008?
Your response must be concise. 1.68. What is the difference between the CO2 emissions (% of total fuel combustion) in Cambodia in 2004 and the CO2 emissions (% of total fuel combustion) in Iran in 2008?
Provide a succinct answer. -14.31. What is the difference between the CO2 emissions (% of total fuel combustion) in Cambodia in 2004 and the CO2 emissions (% of total fuel combustion) in Syrian Arab Republic in 2008?
Give a very brief answer. -1.81. What is the difference between the CO2 emissions (% of total fuel combustion) of Cameroon in 2004 and the CO2 emissions (% of total fuel combustion) of Iran in 2008?
Your response must be concise. -6.82. What is the difference between the CO2 emissions (% of total fuel combustion) in Cameroon in 2004 and the CO2 emissions (% of total fuel combustion) in Syrian Arab Republic in 2008?
Offer a terse response. 5.67. What is the difference between the CO2 emissions (% of total fuel combustion) of Iran in 2004 and the CO2 emissions (% of total fuel combustion) of Syrian Arab Republic in 2008?
Your answer should be compact. 14.86. What is the difference between the CO2 emissions (% of total fuel combustion) in Cambodia in 2005 and the CO2 emissions (% of total fuel combustion) in Cameroon in 2006?
Give a very brief answer. -3.39. What is the difference between the CO2 emissions (% of total fuel combustion) in Cambodia in 2005 and the CO2 emissions (% of total fuel combustion) in Iran in 2006?
Provide a short and direct response. -16.98. What is the difference between the CO2 emissions (% of total fuel combustion) of Cambodia in 2005 and the CO2 emissions (% of total fuel combustion) of Syrian Arab Republic in 2006?
Make the answer very short. -3.66. What is the difference between the CO2 emissions (% of total fuel combustion) in Cameroon in 2005 and the CO2 emissions (% of total fuel combustion) in Iran in 2006?
Give a very brief answer. -10.07. What is the difference between the CO2 emissions (% of total fuel combustion) of Cameroon in 2005 and the CO2 emissions (% of total fuel combustion) of Syrian Arab Republic in 2006?
Provide a succinct answer. 3.25. What is the difference between the CO2 emissions (% of total fuel combustion) of Iran in 2005 and the CO2 emissions (% of total fuel combustion) of Syrian Arab Republic in 2006?
Your answer should be very brief. 12.68. What is the difference between the CO2 emissions (% of total fuel combustion) of Cambodia in 2005 and the CO2 emissions (% of total fuel combustion) of Cameroon in 2007?
Offer a very short reply. 0.47. What is the difference between the CO2 emissions (% of total fuel combustion) in Cambodia in 2005 and the CO2 emissions (% of total fuel combustion) in Iran in 2007?
Keep it short and to the point. -16.97. What is the difference between the CO2 emissions (% of total fuel combustion) of Cambodia in 2005 and the CO2 emissions (% of total fuel combustion) of Syrian Arab Republic in 2007?
Your answer should be very brief. -2.59. What is the difference between the CO2 emissions (% of total fuel combustion) of Cameroon in 2005 and the CO2 emissions (% of total fuel combustion) of Iran in 2007?
Your answer should be very brief. -10.06. What is the difference between the CO2 emissions (% of total fuel combustion) of Cameroon in 2005 and the CO2 emissions (% of total fuel combustion) of Syrian Arab Republic in 2007?
Your answer should be very brief. 4.32. What is the difference between the CO2 emissions (% of total fuel combustion) in Iran in 2005 and the CO2 emissions (% of total fuel combustion) in Syrian Arab Republic in 2007?
Keep it short and to the point. 13.74. What is the difference between the CO2 emissions (% of total fuel combustion) in Cambodia in 2005 and the CO2 emissions (% of total fuel combustion) in Cameroon in 2008?
Provide a short and direct response. 1.02. What is the difference between the CO2 emissions (% of total fuel combustion) of Cambodia in 2005 and the CO2 emissions (% of total fuel combustion) of Iran in 2008?
Provide a short and direct response. -14.96. What is the difference between the CO2 emissions (% of total fuel combustion) of Cambodia in 2005 and the CO2 emissions (% of total fuel combustion) of Syrian Arab Republic in 2008?
Provide a succinct answer. -2.46. What is the difference between the CO2 emissions (% of total fuel combustion) of Cameroon in 2005 and the CO2 emissions (% of total fuel combustion) of Iran in 2008?
Your answer should be very brief. -8.05. What is the difference between the CO2 emissions (% of total fuel combustion) of Cameroon in 2005 and the CO2 emissions (% of total fuel combustion) of Syrian Arab Republic in 2008?
Keep it short and to the point. 4.45. What is the difference between the CO2 emissions (% of total fuel combustion) in Iran in 2005 and the CO2 emissions (% of total fuel combustion) in Syrian Arab Republic in 2008?
Give a very brief answer. 13.87. What is the difference between the CO2 emissions (% of total fuel combustion) of Cambodia in 2006 and the CO2 emissions (% of total fuel combustion) of Cameroon in 2007?
Your answer should be compact. 0.15. What is the difference between the CO2 emissions (% of total fuel combustion) in Cambodia in 2006 and the CO2 emissions (% of total fuel combustion) in Iran in 2007?
Give a very brief answer. -17.29. What is the difference between the CO2 emissions (% of total fuel combustion) in Cambodia in 2006 and the CO2 emissions (% of total fuel combustion) in Syrian Arab Republic in 2007?
Provide a succinct answer. -2.91. What is the difference between the CO2 emissions (% of total fuel combustion) in Cameroon in 2006 and the CO2 emissions (% of total fuel combustion) in Iran in 2007?
Give a very brief answer. -13.58. What is the difference between the CO2 emissions (% of total fuel combustion) of Cameroon in 2006 and the CO2 emissions (% of total fuel combustion) of Syrian Arab Republic in 2007?
Give a very brief answer. 0.8. What is the difference between the CO2 emissions (% of total fuel combustion) in Iran in 2006 and the CO2 emissions (% of total fuel combustion) in Syrian Arab Republic in 2007?
Keep it short and to the point. 14.39. What is the difference between the CO2 emissions (% of total fuel combustion) in Cambodia in 2006 and the CO2 emissions (% of total fuel combustion) in Cameroon in 2008?
Your answer should be compact. 0.7. What is the difference between the CO2 emissions (% of total fuel combustion) of Cambodia in 2006 and the CO2 emissions (% of total fuel combustion) of Iran in 2008?
Keep it short and to the point. -15.28. What is the difference between the CO2 emissions (% of total fuel combustion) in Cambodia in 2006 and the CO2 emissions (% of total fuel combustion) in Syrian Arab Republic in 2008?
Your answer should be compact. -2.78. What is the difference between the CO2 emissions (% of total fuel combustion) in Cameroon in 2006 and the CO2 emissions (% of total fuel combustion) in Iran in 2008?
Your answer should be very brief. -11.57. What is the difference between the CO2 emissions (% of total fuel combustion) in Cameroon in 2006 and the CO2 emissions (% of total fuel combustion) in Syrian Arab Republic in 2008?
Make the answer very short. 0.93. What is the difference between the CO2 emissions (% of total fuel combustion) in Iran in 2006 and the CO2 emissions (% of total fuel combustion) in Syrian Arab Republic in 2008?
Your response must be concise. 14.52. What is the difference between the CO2 emissions (% of total fuel combustion) of Cambodia in 2007 and the CO2 emissions (% of total fuel combustion) of Cameroon in 2008?
Offer a terse response. 0.4. What is the difference between the CO2 emissions (% of total fuel combustion) of Cambodia in 2007 and the CO2 emissions (% of total fuel combustion) of Iran in 2008?
Provide a short and direct response. -15.58. What is the difference between the CO2 emissions (% of total fuel combustion) in Cambodia in 2007 and the CO2 emissions (% of total fuel combustion) in Syrian Arab Republic in 2008?
Ensure brevity in your answer.  -3.08. What is the difference between the CO2 emissions (% of total fuel combustion) in Cameroon in 2007 and the CO2 emissions (% of total fuel combustion) in Iran in 2008?
Offer a very short reply. -15.43. What is the difference between the CO2 emissions (% of total fuel combustion) in Cameroon in 2007 and the CO2 emissions (% of total fuel combustion) in Syrian Arab Republic in 2008?
Provide a succinct answer. -2.93. What is the difference between the CO2 emissions (% of total fuel combustion) in Iran in 2007 and the CO2 emissions (% of total fuel combustion) in Syrian Arab Republic in 2008?
Provide a succinct answer. 14.51. What is the average CO2 emissions (% of total fuel combustion) of Cambodia per year?
Ensure brevity in your answer.  9.53. What is the average CO2 emissions (% of total fuel combustion) of Cameroon per year?
Your answer should be very brief. 15.44. What is the average CO2 emissions (% of total fuel combustion) in Iran per year?
Your response must be concise. 26.31. What is the average CO2 emissions (% of total fuel combustion) in Syrian Arab Republic per year?
Keep it short and to the point. 11.42. In the year 2001, what is the difference between the CO2 emissions (% of total fuel combustion) of Cambodia and CO2 emissions (% of total fuel combustion) of Cameroon?
Provide a succinct answer. -15.23. In the year 2001, what is the difference between the CO2 emissions (% of total fuel combustion) in Cambodia and CO2 emissions (% of total fuel combustion) in Iran?
Give a very brief answer. -19.69. In the year 2001, what is the difference between the CO2 emissions (% of total fuel combustion) of Cambodia and CO2 emissions (% of total fuel combustion) of Syrian Arab Republic?
Provide a short and direct response. -4.53. In the year 2001, what is the difference between the CO2 emissions (% of total fuel combustion) of Cameroon and CO2 emissions (% of total fuel combustion) of Iran?
Provide a short and direct response. -4.46. In the year 2001, what is the difference between the CO2 emissions (% of total fuel combustion) of Cameroon and CO2 emissions (% of total fuel combustion) of Syrian Arab Republic?
Your answer should be very brief. 10.7. In the year 2001, what is the difference between the CO2 emissions (% of total fuel combustion) of Iran and CO2 emissions (% of total fuel combustion) of Syrian Arab Republic?
Keep it short and to the point. 15.16. In the year 2002, what is the difference between the CO2 emissions (% of total fuel combustion) of Cambodia and CO2 emissions (% of total fuel combustion) of Cameroon?
Offer a very short reply. -8.79. In the year 2002, what is the difference between the CO2 emissions (% of total fuel combustion) in Cambodia and CO2 emissions (% of total fuel combustion) in Iran?
Your response must be concise. -17.88. In the year 2002, what is the difference between the CO2 emissions (% of total fuel combustion) of Cambodia and CO2 emissions (% of total fuel combustion) of Syrian Arab Republic?
Give a very brief answer. -0.89. In the year 2002, what is the difference between the CO2 emissions (% of total fuel combustion) of Cameroon and CO2 emissions (% of total fuel combustion) of Iran?
Keep it short and to the point. -9.08. In the year 2002, what is the difference between the CO2 emissions (% of total fuel combustion) of Cameroon and CO2 emissions (% of total fuel combustion) of Syrian Arab Republic?
Your answer should be very brief. 7.9. In the year 2002, what is the difference between the CO2 emissions (% of total fuel combustion) in Iran and CO2 emissions (% of total fuel combustion) in Syrian Arab Republic?
Your answer should be very brief. 16.98. In the year 2003, what is the difference between the CO2 emissions (% of total fuel combustion) of Cambodia and CO2 emissions (% of total fuel combustion) of Cameroon?
Ensure brevity in your answer.  -5.63. In the year 2003, what is the difference between the CO2 emissions (% of total fuel combustion) in Cambodia and CO2 emissions (% of total fuel combustion) in Iran?
Make the answer very short. -13.37. In the year 2003, what is the difference between the CO2 emissions (% of total fuel combustion) of Cambodia and CO2 emissions (% of total fuel combustion) of Syrian Arab Republic?
Make the answer very short. 5.57. In the year 2003, what is the difference between the CO2 emissions (% of total fuel combustion) of Cameroon and CO2 emissions (% of total fuel combustion) of Iran?
Ensure brevity in your answer.  -7.74. In the year 2003, what is the difference between the CO2 emissions (% of total fuel combustion) in Cameroon and CO2 emissions (% of total fuel combustion) in Syrian Arab Republic?
Your response must be concise. 11.2. In the year 2003, what is the difference between the CO2 emissions (% of total fuel combustion) of Iran and CO2 emissions (% of total fuel combustion) of Syrian Arab Republic?
Your response must be concise. 18.94. In the year 2004, what is the difference between the CO2 emissions (% of total fuel combustion) of Cambodia and CO2 emissions (% of total fuel combustion) of Cameroon?
Give a very brief answer. -7.48. In the year 2004, what is the difference between the CO2 emissions (% of total fuel combustion) of Cambodia and CO2 emissions (% of total fuel combustion) of Iran?
Keep it short and to the point. -16.67. In the year 2004, what is the difference between the CO2 emissions (% of total fuel combustion) in Cambodia and CO2 emissions (% of total fuel combustion) in Syrian Arab Republic?
Keep it short and to the point. -1.4. In the year 2004, what is the difference between the CO2 emissions (% of total fuel combustion) in Cameroon and CO2 emissions (% of total fuel combustion) in Iran?
Offer a terse response. -9.19. In the year 2004, what is the difference between the CO2 emissions (% of total fuel combustion) of Cameroon and CO2 emissions (% of total fuel combustion) of Syrian Arab Republic?
Provide a succinct answer. 6.08. In the year 2004, what is the difference between the CO2 emissions (% of total fuel combustion) of Iran and CO2 emissions (% of total fuel combustion) of Syrian Arab Republic?
Offer a very short reply. 15.27. In the year 2005, what is the difference between the CO2 emissions (% of total fuel combustion) of Cambodia and CO2 emissions (% of total fuel combustion) of Cameroon?
Offer a very short reply. -6.91. In the year 2005, what is the difference between the CO2 emissions (% of total fuel combustion) in Cambodia and CO2 emissions (% of total fuel combustion) in Iran?
Keep it short and to the point. -16.33. In the year 2005, what is the difference between the CO2 emissions (% of total fuel combustion) of Cambodia and CO2 emissions (% of total fuel combustion) of Syrian Arab Republic?
Make the answer very short. -3.77. In the year 2005, what is the difference between the CO2 emissions (% of total fuel combustion) of Cameroon and CO2 emissions (% of total fuel combustion) of Iran?
Offer a terse response. -9.42. In the year 2005, what is the difference between the CO2 emissions (% of total fuel combustion) of Cameroon and CO2 emissions (% of total fuel combustion) of Syrian Arab Republic?
Your answer should be compact. 3.14. In the year 2005, what is the difference between the CO2 emissions (% of total fuel combustion) in Iran and CO2 emissions (% of total fuel combustion) in Syrian Arab Republic?
Give a very brief answer. 12.56. In the year 2006, what is the difference between the CO2 emissions (% of total fuel combustion) of Cambodia and CO2 emissions (% of total fuel combustion) of Cameroon?
Ensure brevity in your answer.  -3.71. In the year 2006, what is the difference between the CO2 emissions (% of total fuel combustion) in Cambodia and CO2 emissions (% of total fuel combustion) in Iran?
Your response must be concise. -17.3. In the year 2006, what is the difference between the CO2 emissions (% of total fuel combustion) of Cambodia and CO2 emissions (% of total fuel combustion) of Syrian Arab Republic?
Provide a succinct answer. -3.97. In the year 2006, what is the difference between the CO2 emissions (% of total fuel combustion) in Cameroon and CO2 emissions (% of total fuel combustion) in Iran?
Your answer should be very brief. -13.59. In the year 2006, what is the difference between the CO2 emissions (% of total fuel combustion) of Cameroon and CO2 emissions (% of total fuel combustion) of Syrian Arab Republic?
Offer a terse response. -0.27. In the year 2006, what is the difference between the CO2 emissions (% of total fuel combustion) of Iran and CO2 emissions (% of total fuel combustion) of Syrian Arab Republic?
Provide a short and direct response. 13.32. In the year 2007, what is the difference between the CO2 emissions (% of total fuel combustion) of Cambodia and CO2 emissions (% of total fuel combustion) of Cameroon?
Make the answer very short. -0.15. In the year 2007, what is the difference between the CO2 emissions (% of total fuel combustion) in Cambodia and CO2 emissions (% of total fuel combustion) in Iran?
Make the answer very short. -17.59. In the year 2007, what is the difference between the CO2 emissions (% of total fuel combustion) of Cambodia and CO2 emissions (% of total fuel combustion) of Syrian Arab Republic?
Offer a very short reply. -3.21. In the year 2007, what is the difference between the CO2 emissions (% of total fuel combustion) in Cameroon and CO2 emissions (% of total fuel combustion) in Iran?
Your answer should be very brief. -17.44. In the year 2007, what is the difference between the CO2 emissions (% of total fuel combustion) in Cameroon and CO2 emissions (% of total fuel combustion) in Syrian Arab Republic?
Provide a short and direct response. -3.06. In the year 2007, what is the difference between the CO2 emissions (% of total fuel combustion) in Iran and CO2 emissions (% of total fuel combustion) in Syrian Arab Republic?
Your answer should be very brief. 14.38. In the year 2008, what is the difference between the CO2 emissions (% of total fuel combustion) in Cambodia and CO2 emissions (% of total fuel combustion) in Cameroon?
Provide a succinct answer. 0.61. In the year 2008, what is the difference between the CO2 emissions (% of total fuel combustion) of Cambodia and CO2 emissions (% of total fuel combustion) of Iran?
Make the answer very short. -15.37. In the year 2008, what is the difference between the CO2 emissions (% of total fuel combustion) in Cambodia and CO2 emissions (% of total fuel combustion) in Syrian Arab Republic?
Your answer should be very brief. -2.87. In the year 2008, what is the difference between the CO2 emissions (% of total fuel combustion) in Cameroon and CO2 emissions (% of total fuel combustion) in Iran?
Offer a very short reply. -15.98. In the year 2008, what is the difference between the CO2 emissions (% of total fuel combustion) of Cameroon and CO2 emissions (% of total fuel combustion) of Syrian Arab Republic?
Ensure brevity in your answer.  -3.48. In the year 2008, what is the difference between the CO2 emissions (% of total fuel combustion) in Iran and CO2 emissions (% of total fuel combustion) in Syrian Arab Republic?
Keep it short and to the point. 12.5. What is the ratio of the CO2 emissions (% of total fuel combustion) in Cambodia in 2001 to that in 2002?
Provide a succinct answer. 0.69. What is the ratio of the CO2 emissions (% of total fuel combustion) of Cameroon in 2001 to that in 2002?
Your response must be concise. 1.19. What is the ratio of the CO2 emissions (% of total fuel combustion) of Iran in 2001 to that in 2002?
Give a very brief answer. 0.96. What is the ratio of the CO2 emissions (% of total fuel combustion) in Syrian Arab Republic in 2001 to that in 2002?
Offer a very short reply. 1.06. What is the ratio of the CO2 emissions (% of total fuel combustion) in Cambodia in 2001 to that in 2003?
Provide a succinct answer. 0.48. What is the ratio of the CO2 emissions (% of total fuel combustion) in Cameroon in 2001 to that in 2003?
Offer a very short reply. 1.14. What is the ratio of the CO2 emissions (% of total fuel combustion) of Iran in 2001 to that in 2003?
Make the answer very short. 0.98. What is the ratio of the CO2 emissions (% of total fuel combustion) in Syrian Arab Republic in 2001 to that in 2003?
Offer a very short reply. 1.4. What is the ratio of the CO2 emissions (% of total fuel combustion) in Cambodia in 2001 to that in 2004?
Offer a terse response. 0.65. What is the ratio of the CO2 emissions (% of total fuel combustion) of Cameroon in 2001 to that in 2004?
Make the answer very short. 1.24. What is the ratio of the CO2 emissions (% of total fuel combustion) of Iran in 2001 to that in 2004?
Your response must be concise. 0.98. What is the ratio of the CO2 emissions (% of total fuel combustion) of Syrian Arab Republic in 2001 to that in 2004?
Your answer should be very brief. 0.96. What is the ratio of the CO2 emissions (% of total fuel combustion) in Cambodia in 2001 to that in 2005?
Provide a short and direct response. 0.69. What is the ratio of the CO2 emissions (% of total fuel combustion) of Cameroon in 2001 to that in 2005?
Your answer should be compact. 1.33. What is the ratio of the CO2 emissions (% of total fuel combustion) in Iran in 2001 to that in 2005?
Ensure brevity in your answer.  1.02. What is the ratio of the CO2 emissions (% of total fuel combustion) in Syrian Arab Republic in 2001 to that in 2005?
Offer a terse response. 0.84. What is the ratio of the CO2 emissions (% of total fuel combustion) of Cambodia in 2001 to that in 2006?
Your response must be concise. 0.71. What is the ratio of the CO2 emissions (% of total fuel combustion) in Cameroon in 2001 to that in 2006?
Your answer should be very brief. 1.69. What is the ratio of the CO2 emissions (% of total fuel combustion) in Syrian Arab Republic in 2001 to that in 2006?
Offer a terse response. 0.84. What is the ratio of the CO2 emissions (% of total fuel combustion) of Cambodia in 2001 to that in 2007?
Ensure brevity in your answer.  0.74. What is the ratio of the CO2 emissions (% of total fuel combustion) in Cameroon in 2001 to that in 2007?
Ensure brevity in your answer.  2.42. What is the ratio of the CO2 emissions (% of total fuel combustion) in Iran in 2001 to that in 2007?
Your answer should be compact. 0.99. What is the ratio of the CO2 emissions (% of total fuel combustion) of Syrian Arab Republic in 2001 to that in 2007?
Offer a terse response. 0.92. What is the ratio of the CO2 emissions (% of total fuel combustion) of Cambodia in 2001 to that in 2008?
Give a very brief answer. 0.72. What is the ratio of the CO2 emissions (% of total fuel combustion) in Cameroon in 2001 to that in 2008?
Offer a terse response. 2.58. What is the ratio of the CO2 emissions (% of total fuel combustion) in Iran in 2001 to that in 2008?
Ensure brevity in your answer.  1.07. What is the ratio of the CO2 emissions (% of total fuel combustion) of Syrian Arab Republic in 2001 to that in 2008?
Keep it short and to the point. 0.93. What is the ratio of the CO2 emissions (% of total fuel combustion) in Cambodia in 2002 to that in 2003?
Your answer should be compact. 0.71. What is the ratio of the CO2 emissions (% of total fuel combustion) in Cameroon in 2002 to that in 2003?
Provide a succinct answer. 0.96. What is the ratio of the CO2 emissions (% of total fuel combustion) of Iran in 2002 to that in 2003?
Provide a short and direct response. 1.02. What is the ratio of the CO2 emissions (% of total fuel combustion) of Syrian Arab Republic in 2002 to that in 2003?
Offer a very short reply. 1.32. What is the ratio of the CO2 emissions (% of total fuel combustion) in Cambodia in 2002 to that in 2004?
Give a very brief answer. 0.94. What is the ratio of the CO2 emissions (% of total fuel combustion) in Cameroon in 2002 to that in 2004?
Make the answer very short. 1.04. What is the ratio of the CO2 emissions (% of total fuel combustion) in Iran in 2002 to that in 2004?
Keep it short and to the point. 1.02. What is the ratio of the CO2 emissions (% of total fuel combustion) in Syrian Arab Republic in 2002 to that in 2004?
Your answer should be very brief. 0.91. What is the ratio of the CO2 emissions (% of total fuel combustion) of Cambodia in 2002 to that in 2005?
Give a very brief answer. 1.01. What is the ratio of the CO2 emissions (% of total fuel combustion) in Cameroon in 2002 to that in 2005?
Keep it short and to the point. 1.12. What is the ratio of the CO2 emissions (% of total fuel combustion) of Iran in 2002 to that in 2005?
Your response must be concise. 1.06. What is the ratio of the CO2 emissions (% of total fuel combustion) of Syrian Arab Republic in 2002 to that in 2005?
Your answer should be compact. 0.79. What is the ratio of the CO2 emissions (% of total fuel combustion) of Cambodia in 2002 to that in 2006?
Give a very brief answer. 1.04. What is the ratio of the CO2 emissions (% of total fuel combustion) in Cameroon in 2002 to that in 2006?
Offer a very short reply. 1.43. What is the ratio of the CO2 emissions (% of total fuel combustion) in Iran in 2002 to that in 2006?
Keep it short and to the point. 1.04. What is the ratio of the CO2 emissions (% of total fuel combustion) of Syrian Arab Republic in 2002 to that in 2006?
Offer a terse response. 0.8. What is the ratio of the CO2 emissions (% of total fuel combustion) of Cambodia in 2002 to that in 2007?
Your answer should be compact. 1.08. What is the ratio of the CO2 emissions (% of total fuel combustion) of Cameroon in 2002 to that in 2007?
Your response must be concise. 2.04. What is the ratio of the CO2 emissions (% of total fuel combustion) in Iran in 2002 to that in 2007?
Your answer should be compact. 1.04. What is the ratio of the CO2 emissions (% of total fuel combustion) of Syrian Arab Republic in 2002 to that in 2007?
Your answer should be very brief. 0.87. What is the ratio of the CO2 emissions (% of total fuel combustion) in Cambodia in 2002 to that in 2008?
Keep it short and to the point. 1.05. What is the ratio of the CO2 emissions (% of total fuel combustion) in Cameroon in 2002 to that in 2008?
Offer a terse response. 2.17. What is the ratio of the CO2 emissions (% of total fuel combustion) of Iran in 2002 to that in 2008?
Your answer should be compact. 1.12. What is the ratio of the CO2 emissions (% of total fuel combustion) of Syrian Arab Republic in 2002 to that in 2008?
Provide a short and direct response. 0.87. What is the ratio of the CO2 emissions (% of total fuel combustion) of Cambodia in 2003 to that in 2004?
Provide a succinct answer. 1.33. What is the ratio of the CO2 emissions (% of total fuel combustion) in Cameroon in 2003 to that in 2004?
Give a very brief answer. 1.09. What is the ratio of the CO2 emissions (% of total fuel combustion) in Syrian Arab Republic in 2003 to that in 2004?
Keep it short and to the point. 0.69. What is the ratio of the CO2 emissions (% of total fuel combustion) in Cambodia in 2003 to that in 2005?
Make the answer very short. 1.43. What is the ratio of the CO2 emissions (% of total fuel combustion) of Cameroon in 2003 to that in 2005?
Offer a terse response. 1.17. What is the ratio of the CO2 emissions (% of total fuel combustion) of Iran in 2003 to that in 2005?
Ensure brevity in your answer.  1.04. What is the ratio of the CO2 emissions (% of total fuel combustion) in Syrian Arab Republic in 2003 to that in 2005?
Offer a very short reply. 0.6. What is the ratio of the CO2 emissions (% of total fuel combustion) in Cambodia in 2003 to that in 2006?
Provide a succinct answer. 1.48. What is the ratio of the CO2 emissions (% of total fuel combustion) of Cameroon in 2003 to that in 2006?
Offer a terse response. 1.49. What is the ratio of the CO2 emissions (% of total fuel combustion) of Iran in 2003 to that in 2006?
Your answer should be compact. 1.02. What is the ratio of the CO2 emissions (% of total fuel combustion) of Syrian Arab Republic in 2003 to that in 2006?
Ensure brevity in your answer.  0.6. What is the ratio of the CO2 emissions (% of total fuel combustion) in Cambodia in 2003 to that in 2007?
Give a very brief answer. 1.53. What is the ratio of the CO2 emissions (% of total fuel combustion) of Cameroon in 2003 to that in 2007?
Make the answer very short. 2.12. What is the ratio of the CO2 emissions (% of total fuel combustion) of Iran in 2003 to that in 2007?
Give a very brief answer. 1.02. What is the ratio of the CO2 emissions (% of total fuel combustion) of Syrian Arab Republic in 2003 to that in 2007?
Ensure brevity in your answer.  0.66. What is the ratio of the CO2 emissions (% of total fuel combustion) in Cambodia in 2003 to that in 2008?
Provide a succinct answer. 1.49. What is the ratio of the CO2 emissions (% of total fuel combustion) in Cameroon in 2003 to that in 2008?
Give a very brief answer. 2.26. What is the ratio of the CO2 emissions (% of total fuel combustion) in Iran in 2003 to that in 2008?
Offer a very short reply. 1.1. What is the ratio of the CO2 emissions (% of total fuel combustion) of Syrian Arab Republic in 2003 to that in 2008?
Make the answer very short. 0.66. What is the ratio of the CO2 emissions (% of total fuel combustion) in Cambodia in 2004 to that in 2005?
Make the answer very short. 1.07. What is the ratio of the CO2 emissions (% of total fuel combustion) of Cameroon in 2004 to that in 2005?
Ensure brevity in your answer.  1.07. What is the ratio of the CO2 emissions (% of total fuel combustion) in Iran in 2004 to that in 2005?
Offer a terse response. 1.04. What is the ratio of the CO2 emissions (% of total fuel combustion) in Syrian Arab Republic in 2004 to that in 2005?
Provide a short and direct response. 0.87. What is the ratio of the CO2 emissions (% of total fuel combustion) in Cambodia in 2004 to that in 2006?
Provide a short and direct response. 1.11. What is the ratio of the CO2 emissions (% of total fuel combustion) in Cameroon in 2004 to that in 2006?
Your answer should be compact. 1.37. What is the ratio of the CO2 emissions (% of total fuel combustion) of Iran in 2004 to that in 2006?
Offer a very short reply. 1.01. What is the ratio of the CO2 emissions (% of total fuel combustion) in Syrian Arab Republic in 2004 to that in 2006?
Provide a succinct answer. 0.88. What is the ratio of the CO2 emissions (% of total fuel combustion) of Cambodia in 2004 to that in 2007?
Give a very brief answer. 1.14. What is the ratio of the CO2 emissions (% of total fuel combustion) of Cameroon in 2004 to that in 2007?
Ensure brevity in your answer.  1.96. What is the ratio of the CO2 emissions (% of total fuel combustion) of Iran in 2004 to that in 2007?
Offer a terse response. 1.01. What is the ratio of the CO2 emissions (% of total fuel combustion) in Syrian Arab Republic in 2004 to that in 2007?
Make the answer very short. 0.96. What is the ratio of the CO2 emissions (% of total fuel combustion) of Cambodia in 2004 to that in 2008?
Provide a succinct answer. 1.12. What is the ratio of the CO2 emissions (% of total fuel combustion) of Cameroon in 2004 to that in 2008?
Give a very brief answer. 2.08. What is the ratio of the CO2 emissions (% of total fuel combustion) of Iran in 2004 to that in 2008?
Ensure brevity in your answer.  1.1. What is the ratio of the CO2 emissions (% of total fuel combustion) in Syrian Arab Republic in 2004 to that in 2008?
Your response must be concise. 0.97. What is the ratio of the CO2 emissions (% of total fuel combustion) in Cambodia in 2005 to that in 2006?
Ensure brevity in your answer.  1.03. What is the ratio of the CO2 emissions (% of total fuel combustion) in Cameroon in 2005 to that in 2006?
Your response must be concise. 1.27. What is the ratio of the CO2 emissions (% of total fuel combustion) of Iran in 2005 to that in 2006?
Your answer should be very brief. 0.98. What is the ratio of the CO2 emissions (% of total fuel combustion) in Syrian Arab Republic in 2005 to that in 2006?
Your answer should be compact. 1.01. What is the ratio of the CO2 emissions (% of total fuel combustion) of Cambodia in 2005 to that in 2007?
Your answer should be compact. 1.07. What is the ratio of the CO2 emissions (% of total fuel combustion) in Cameroon in 2005 to that in 2007?
Give a very brief answer. 1.82. What is the ratio of the CO2 emissions (% of total fuel combustion) of Iran in 2005 to that in 2007?
Keep it short and to the point. 0.98. What is the ratio of the CO2 emissions (% of total fuel combustion) in Syrian Arab Republic in 2005 to that in 2007?
Make the answer very short. 1.1. What is the ratio of the CO2 emissions (% of total fuel combustion) of Cambodia in 2005 to that in 2008?
Make the answer very short. 1.04. What is the ratio of the CO2 emissions (% of total fuel combustion) in Cameroon in 2005 to that in 2008?
Keep it short and to the point. 1.94. What is the ratio of the CO2 emissions (% of total fuel combustion) of Iran in 2005 to that in 2008?
Your answer should be compact. 1.06. What is the ratio of the CO2 emissions (% of total fuel combustion) of Syrian Arab Republic in 2005 to that in 2008?
Provide a short and direct response. 1.11. What is the ratio of the CO2 emissions (% of total fuel combustion) in Cambodia in 2006 to that in 2007?
Your answer should be compact. 1.03. What is the ratio of the CO2 emissions (% of total fuel combustion) in Cameroon in 2006 to that in 2007?
Provide a succinct answer. 1.43. What is the ratio of the CO2 emissions (% of total fuel combustion) in Syrian Arab Republic in 2006 to that in 2007?
Make the answer very short. 1.09. What is the ratio of the CO2 emissions (% of total fuel combustion) in Cambodia in 2006 to that in 2008?
Your answer should be compact. 1.01. What is the ratio of the CO2 emissions (% of total fuel combustion) of Cameroon in 2006 to that in 2008?
Provide a succinct answer. 1.52. What is the ratio of the CO2 emissions (% of total fuel combustion) in Iran in 2006 to that in 2008?
Offer a terse response. 1.08. What is the ratio of the CO2 emissions (% of total fuel combustion) of Syrian Arab Republic in 2006 to that in 2008?
Provide a short and direct response. 1.1. What is the ratio of the CO2 emissions (% of total fuel combustion) of Cambodia in 2007 to that in 2008?
Your answer should be compact. 0.98. What is the ratio of the CO2 emissions (% of total fuel combustion) in Cameroon in 2007 to that in 2008?
Your answer should be very brief. 1.07. What is the ratio of the CO2 emissions (% of total fuel combustion) of Iran in 2007 to that in 2008?
Offer a terse response. 1.08. What is the ratio of the CO2 emissions (% of total fuel combustion) of Syrian Arab Republic in 2007 to that in 2008?
Give a very brief answer. 1.01. What is the difference between the highest and the second highest CO2 emissions (% of total fuel combustion) in Cambodia?
Make the answer very short. 3.38. What is the difference between the highest and the second highest CO2 emissions (% of total fuel combustion) in Cameroon?
Your answer should be very brief. 2.64. What is the difference between the highest and the second highest CO2 emissions (% of total fuel combustion) in Iran?
Offer a very short reply. 0.55. What is the difference between the highest and the second highest CO2 emissions (% of total fuel combustion) of Syrian Arab Republic?
Offer a terse response. 0.11. What is the difference between the highest and the lowest CO2 emissions (% of total fuel combustion) in Cambodia?
Give a very brief answer. 6.96. What is the difference between the highest and the lowest CO2 emissions (% of total fuel combustion) in Cameroon?
Your answer should be very brief. 13.32. What is the difference between the highest and the lowest CO2 emissions (% of total fuel combustion) of Iran?
Your answer should be compact. 2.99. What is the difference between the highest and the lowest CO2 emissions (% of total fuel combustion) in Syrian Arab Republic?
Your answer should be very brief. 5.31. 